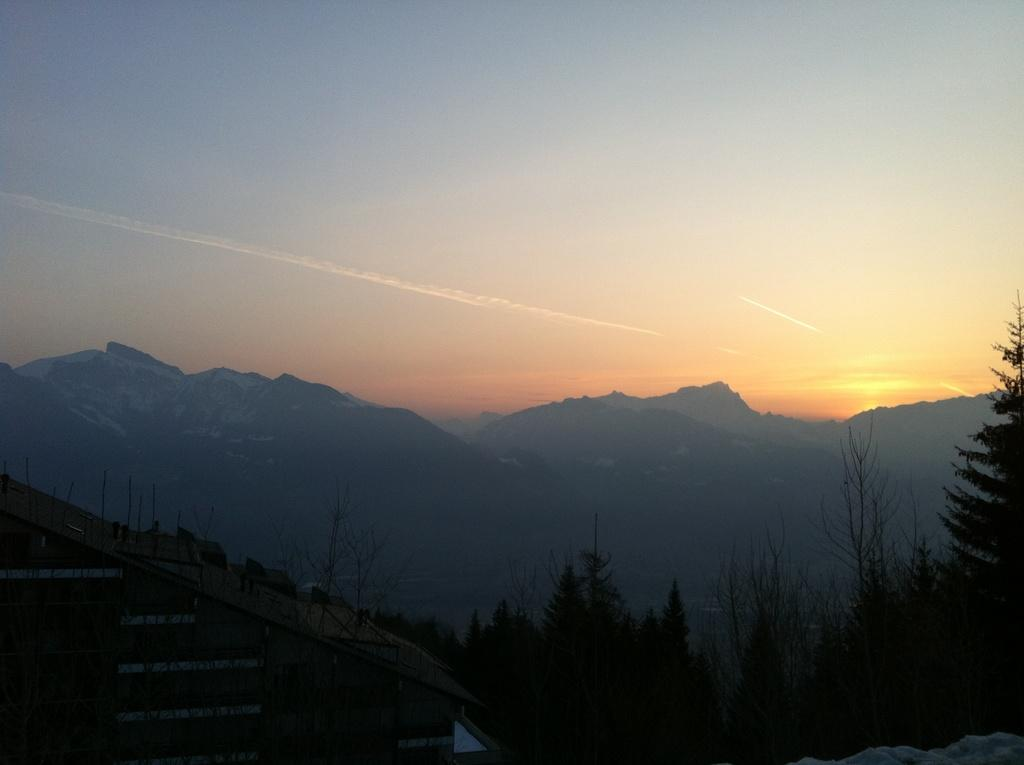What type of natural scenery can be seen in the background of the image? There are trees and mountains in the background of the image. Can you describe the landscape in the image? The landscape in the image features trees and mountains in the background. How many bikes are visible in the image? There are no bikes present in the image. What type of regret can be seen on the faces of the people in the image? There are no people present in the image, so it is not possible to determine if they are experiencing regret. 